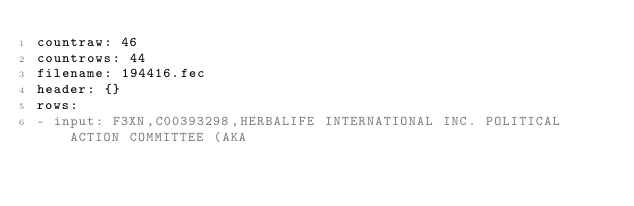Convert code to text. <code><loc_0><loc_0><loc_500><loc_500><_YAML_>countraw: 46
countrows: 44
filename: 194416.fec
header: {}
rows:
- input: F3XN,C00393298,HERBALIFE INTERNATIONAL INC. POLITICAL ACTION COMMITTEE (AKA</code> 